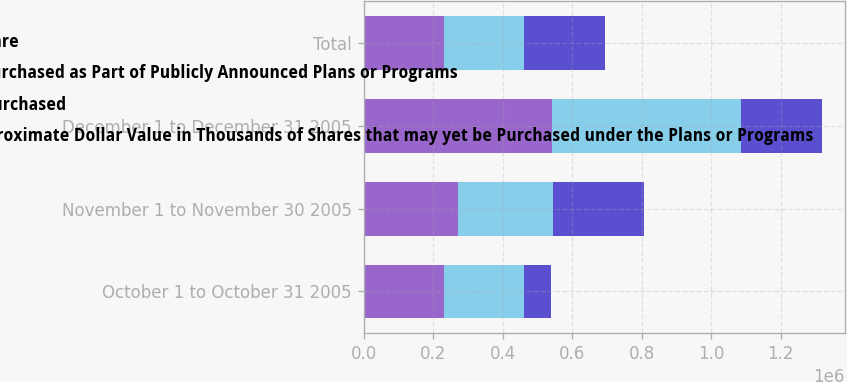Convert chart. <chart><loc_0><loc_0><loc_500><loc_500><stacked_bar_chart><ecel><fcel>October 1 to October 31 2005<fcel>November 1 to November 30 2005<fcel>December 1 to December 31 2005<fcel>Total<nl><fcel>b Average Price Paid per Share<fcel>231000<fcel>273000<fcel>543400<fcel>231310<nl><fcel>c Total Number of Shares Purchased as Part of Publicly Announced Plans or Programs<fcel>51.42<fcel>55.35<fcel>56.74<fcel>55.2<nl><fcel>a Total Number of Shares Purchased<fcel>231000<fcel>273000<fcel>543400<fcel>231310<nl><fcel>d Maximum Number or Approximate Dollar Value in Thousands of Shares that may yet be Purchased under the Plans or Programs<fcel>77585<fcel>262467<fcel>231619<fcel>231619<nl></chart> 